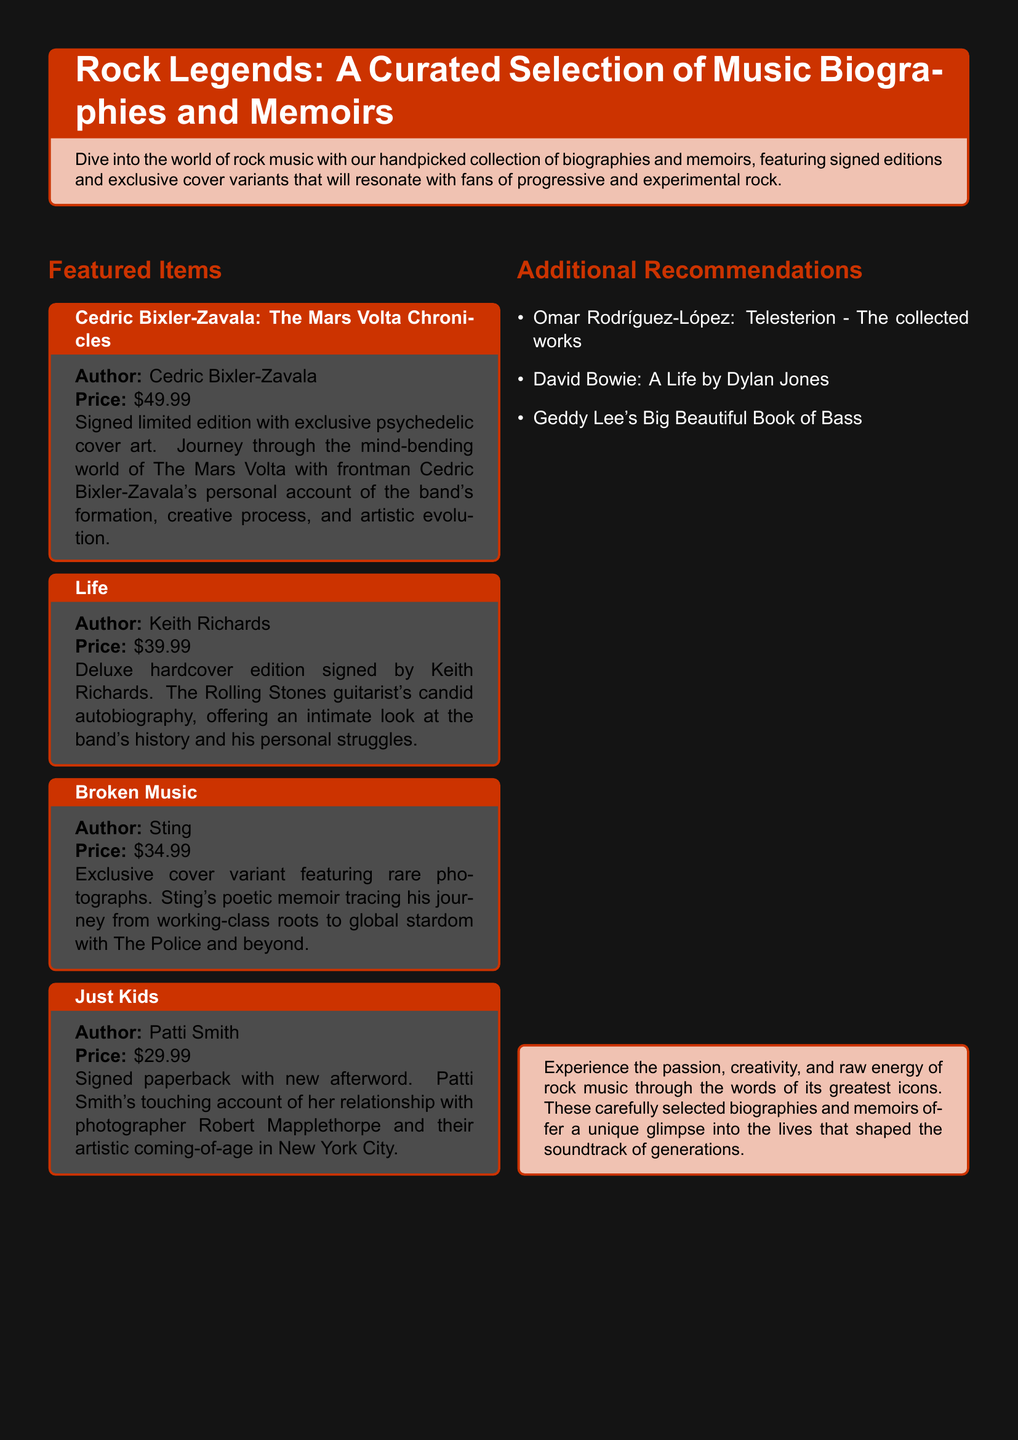what is the title of Cedric Bixler-Zavala's biography? The title is explicitly stated in the document under the featured items section.
Answer: The Mars Volta Chronicles how much does the signed edition of "Life" cost? The price for the signed deluxe hardcover edition is noted in the document.
Answer: $39.99 name one additional recommendation from the list provided. The document features additional recommendations in a bulleted list.
Answer: Omar Rodríguez-López: Telesterion - The collected works who is the author of "Just Kids"? The author is mentioned underneath the title in the featured items section.
Answer: Patti Smith which biography includes an exclusive cover variant with rare photographs? The document specifies which items feature exclusive cover variants and includes details about them.
Answer: Broken Music how many featured items are listed in the document? The number of featured items can be counted from those presented in the featured items section.
Answer: Four what type of cover art is featured on Cedric Bixler-Zavala's signed edition? The document describes the cover art associated with this specific item.
Answer: Exclusive psychedelic cover art what is a unique feature of "Just Kids"? The document lists features specific to each item in the featured items section.
Answer: Signed paperback with new afterword 